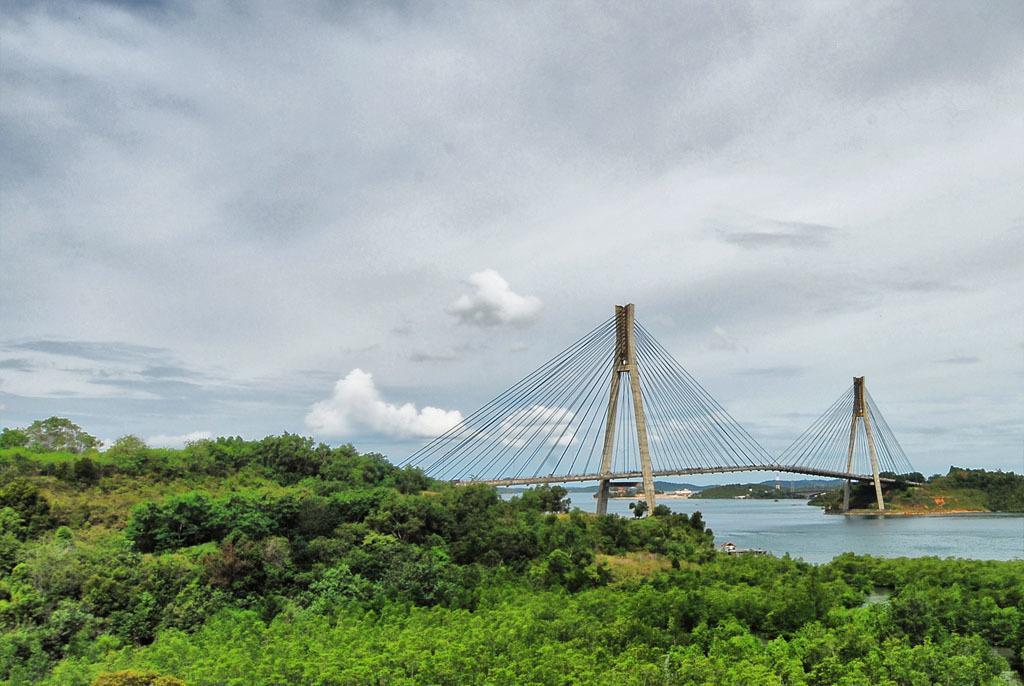In one or two sentences, can you explain what this image depicts? In the picture we can see group of plants and near it, we can see water with a bridge from one corner to another hill and in the background also we can see some hills and sky with clouds. 